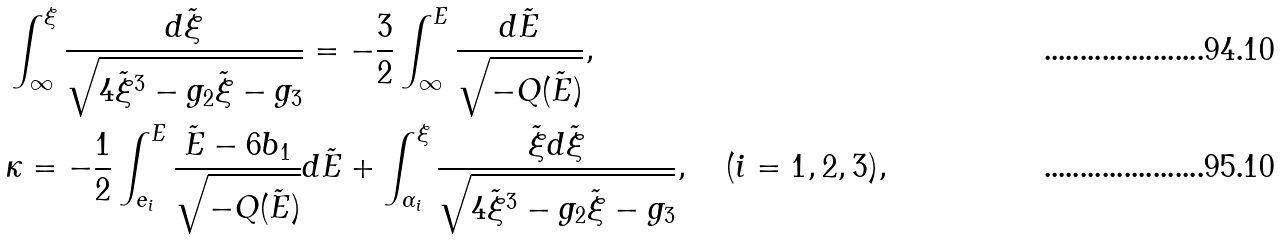<formula> <loc_0><loc_0><loc_500><loc_500>& \int _ { \infty } ^ { \xi } \frac { d \tilde { \xi } } { \sqrt { 4 \tilde { \xi } ^ { 3 } - g _ { 2 } \tilde { \xi } - g _ { 3 } } } = - \frac { 3 } { 2 } \int _ { \infty } ^ { E } \frac { d \tilde { E } } { \sqrt { - Q ( \tilde { E } ) } } , \\ & \kappa = - \frac { 1 } { 2 } \int _ { e _ { i } } ^ { E } \frac { \tilde { E } - 6 b _ { 1 } } { \sqrt { - Q ( \tilde { E } ) } } d \tilde { E } + \int _ { \alpha _ { i } } ^ { \xi } \frac { \tilde { \xi } d \tilde { \xi } } { \sqrt { 4 \tilde { \xi } ^ { 3 } - g _ { 2 } \tilde { \xi } - g _ { 3 } } } , \quad ( i = 1 , 2 , 3 ) ,</formula> 